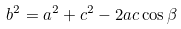Convert formula to latex. <formula><loc_0><loc_0><loc_500><loc_500>b ^ { 2 } = a ^ { 2 } + c ^ { 2 } - 2 a c \cos \beta</formula> 